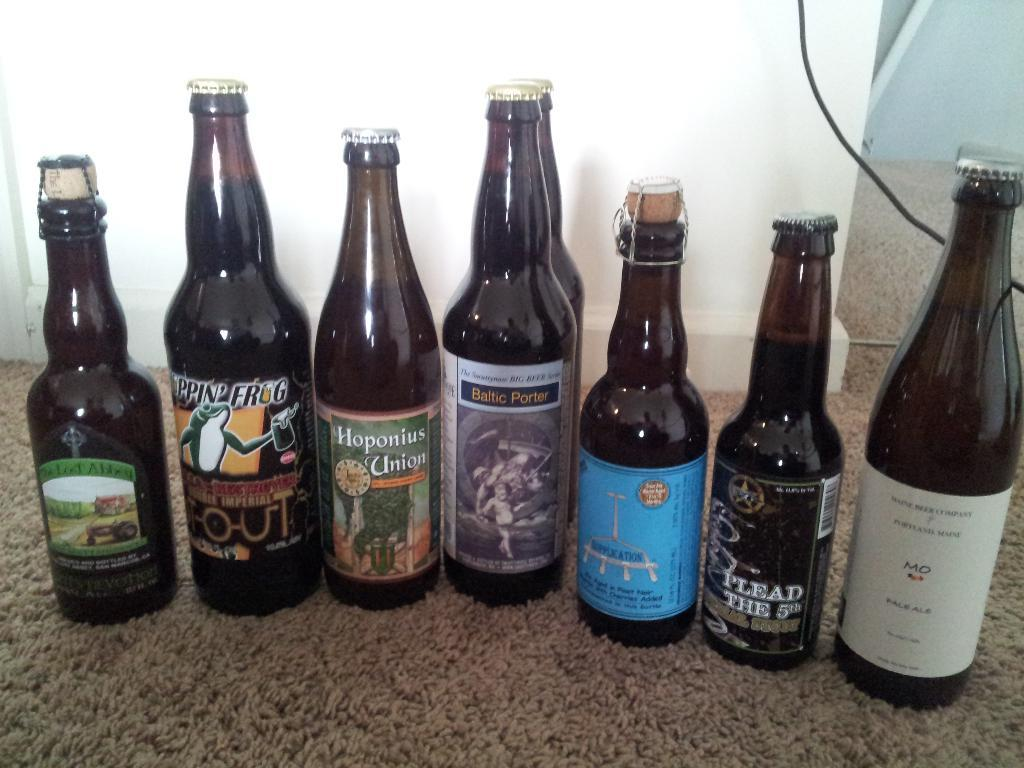<image>
Describe the image concisely. Amongst six other bottles is a bottle of Hoponius Union. 